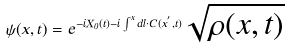<formula> <loc_0><loc_0><loc_500><loc_500>\psi ( { x } , t ) = e ^ { - i X _ { 0 } ( t ) - i \int ^ { x } d { l } \cdot { C } ( { x } ^ { ^ { \prime } } , t ) } \sqrt { \rho ( { x } , t ) }</formula> 